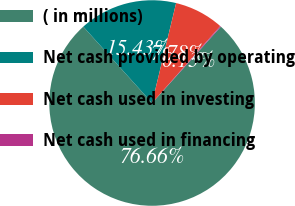<chart> <loc_0><loc_0><loc_500><loc_500><pie_chart><fcel>( in millions)<fcel>Net cash provided by operating<fcel>Net cash used in investing<fcel>Net cash used in financing<nl><fcel>76.65%<fcel>15.43%<fcel>7.78%<fcel>0.13%<nl></chart> 